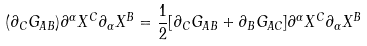<formula> <loc_0><loc_0><loc_500><loc_500>( \partial _ { C } G _ { A B } ) \partial ^ { \alpha } X ^ { C } \partial _ { \alpha } X ^ { B } = \frac { 1 } { 2 } [ \partial _ { C } G _ { A B } + \partial _ { B } G _ { A C } ] \partial ^ { \alpha } X ^ { C } \partial _ { \alpha } X ^ { B }</formula> 